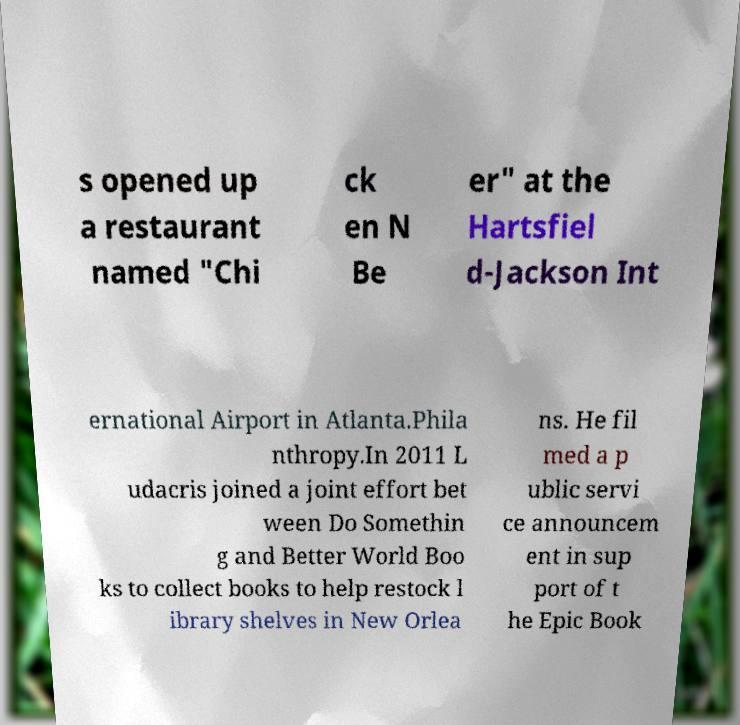Can you accurately transcribe the text from the provided image for me? s opened up a restaurant named "Chi ck en N Be er" at the Hartsfiel d-Jackson Int ernational Airport in Atlanta.Phila nthropy.In 2011 L udacris joined a joint effort bet ween Do Somethin g and Better World Boo ks to collect books to help restock l ibrary shelves in New Orlea ns. He fil med a p ublic servi ce announcem ent in sup port of t he Epic Book 